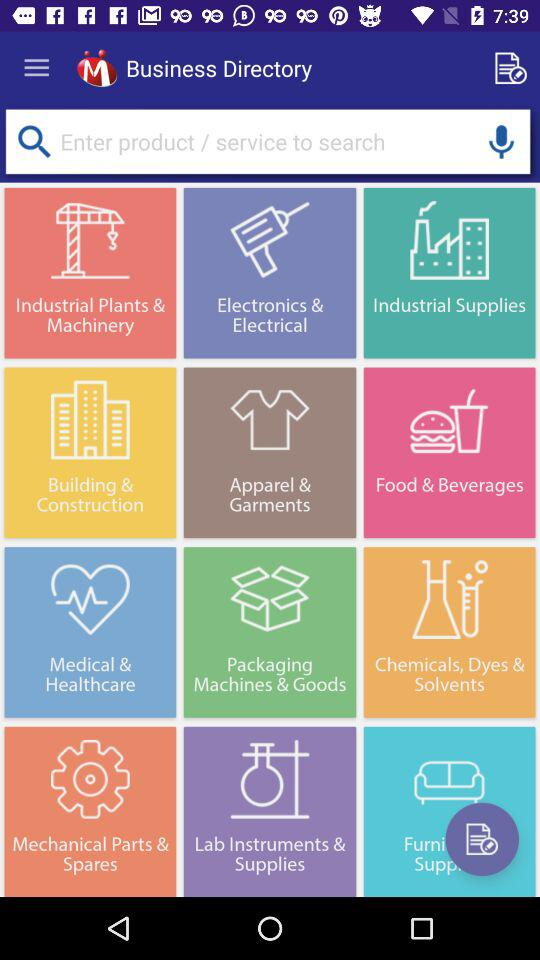What is the application name? The application name is "Business Directory". 